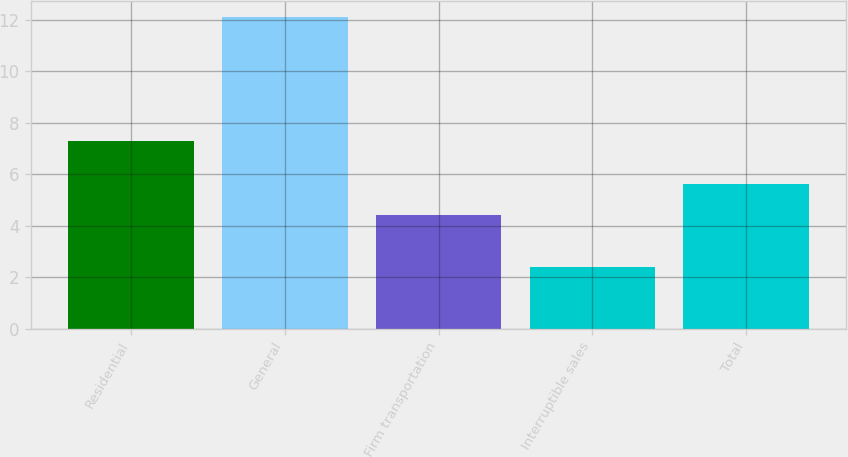Convert chart to OTSL. <chart><loc_0><loc_0><loc_500><loc_500><bar_chart><fcel>Residential<fcel>General<fcel>Firm transportation<fcel>Interruptible sales<fcel>Total<nl><fcel>7.3<fcel>12.1<fcel>4.4<fcel>2.4<fcel>5.6<nl></chart> 